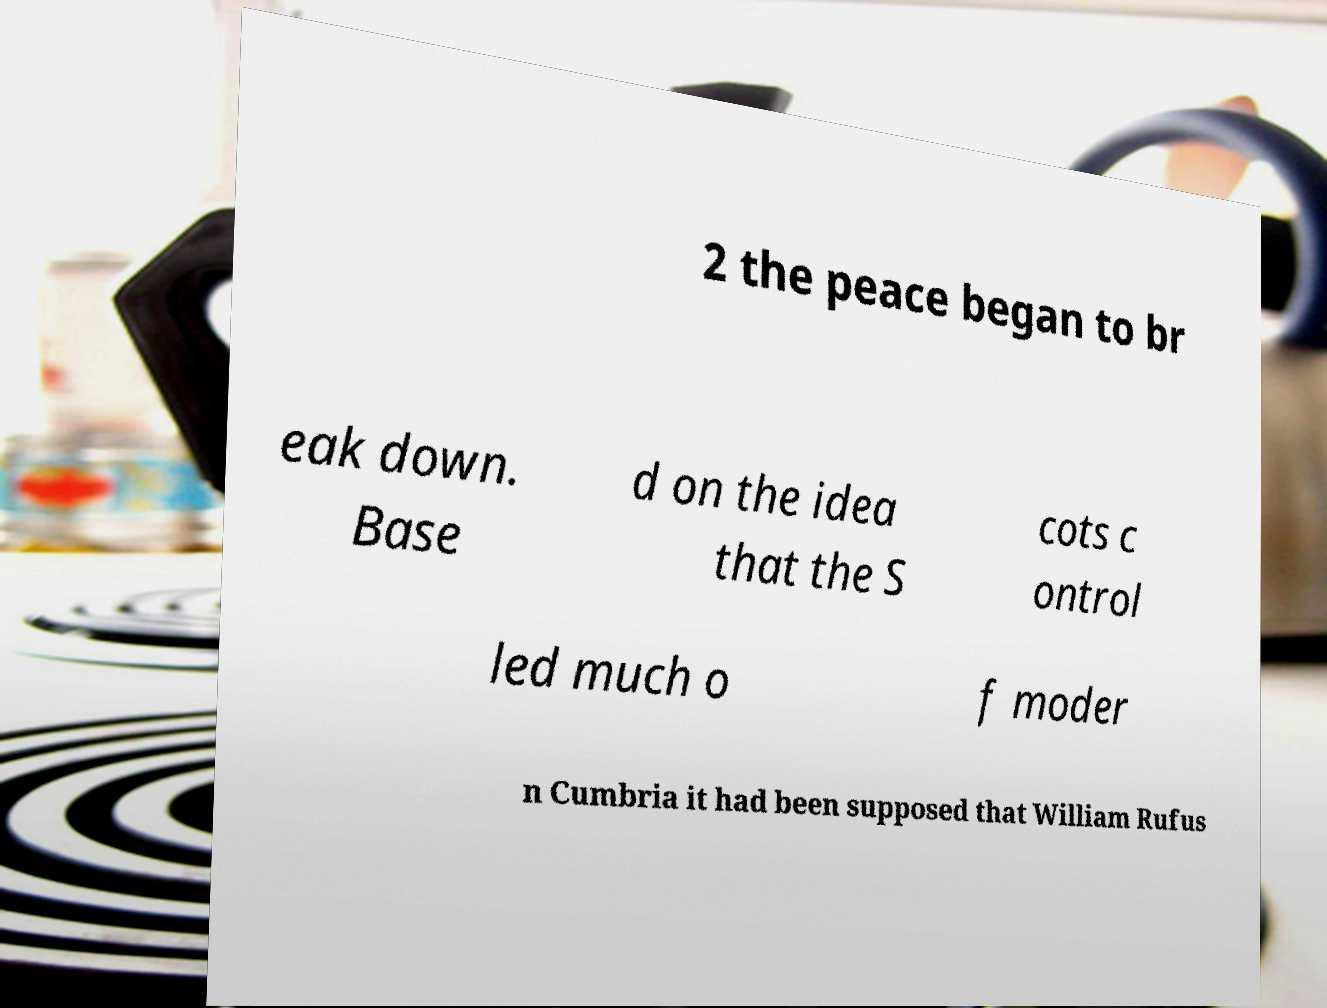Please identify and transcribe the text found in this image. 2 the peace began to br eak down. Base d on the idea that the S cots c ontrol led much o f moder n Cumbria it had been supposed that William Rufus 